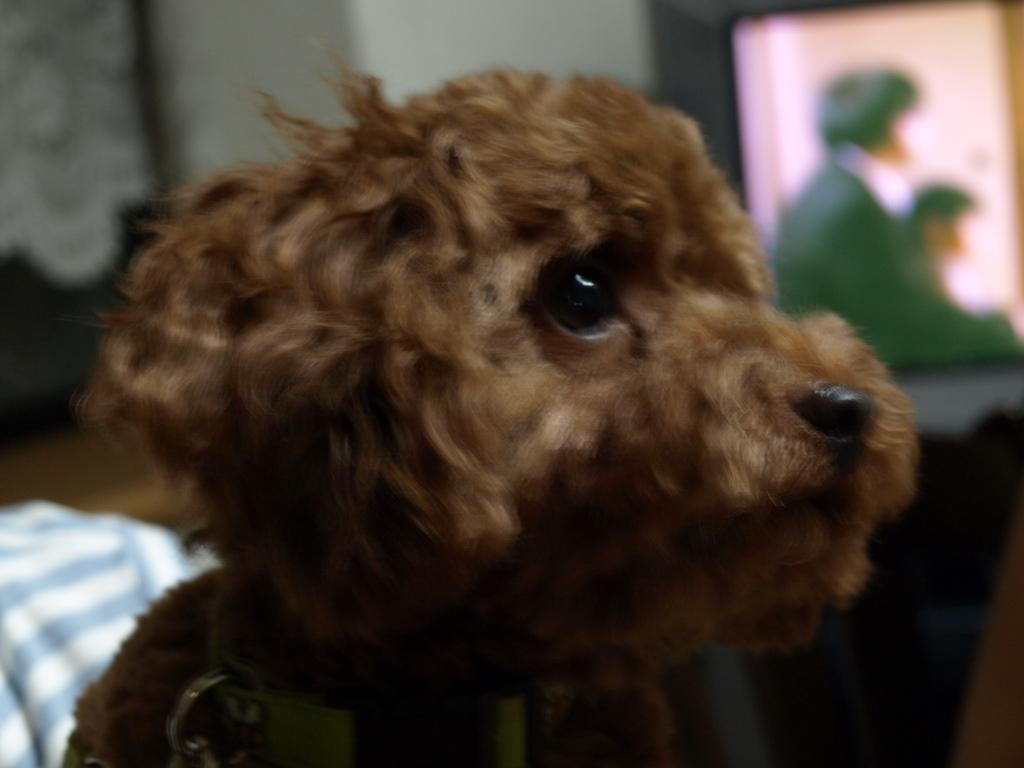What type of animal is in the image? There is a dog in the image. Can you describe the background of the image? The background of the image is blurry. What type of transport can be seen in the image? There is no transport visible in the image; it only features a dog and a blurry background. How much salt is present in the image? There is no salt present in the image. 